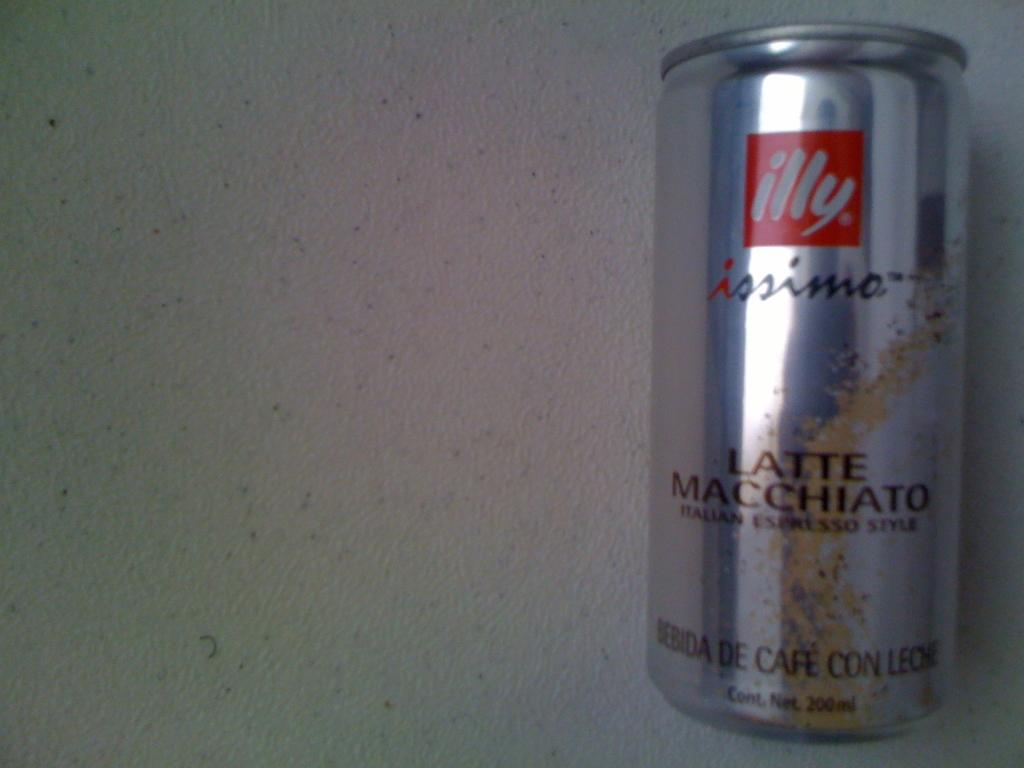<image>
Create a compact narrative representing the image presented. Silver can of Latte Macchiato which says illy on it. 